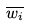Convert formula to latex. <formula><loc_0><loc_0><loc_500><loc_500>\overline { w _ { i } }</formula> 